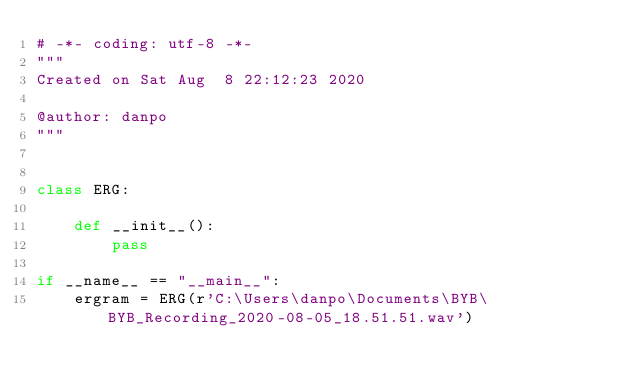Convert code to text. <code><loc_0><loc_0><loc_500><loc_500><_Python_># -*- coding: utf-8 -*-
"""
Created on Sat Aug  8 22:12:23 2020

@author: danpo
"""


class ERG:
    
    def __init__():
        pass

if __name__ == "__main__":
    ergram = ERG(r'C:\Users\danpo\Documents\BYB\BYB_Recording_2020-08-05_18.51.51.wav')
</code> 